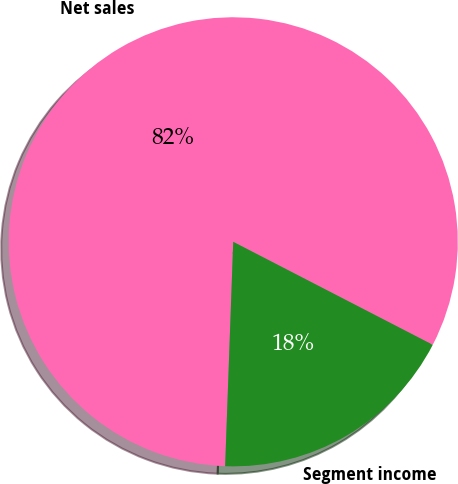Convert chart to OTSL. <chart><loc_0><loc_0><loc_500><loc_500><pie_chart><fcel>Net sales<fcel>Segment income<nl><fcel>82.01%<fcel>17.99%<nl></chart> 